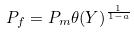Convert formula to latex. <formula><loc_0><loc_0><loc_500><loc_500>P _ { f } = P _ { m } \theta ( Y ) ^ { \frac { 1 } { 1 - a } }</formula> 